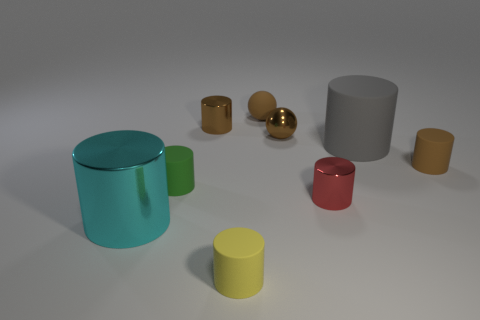Subtract all gray cylinders. How many cylinders are left? 6 Subtract all tiny red metal cylinders. How many cylinders are left? 6 Subtract all blue cylinders. Subtract all cyan blocks. How many cylinders are left? 7 Subtract all balls. How many objects are left? 7 Subtract all tiny brown shiny balls. Subtract all small rubber objects. How many objects are left? 4 Add 1 green objects. How many green objects are left? 2 Add 9 green spheres. How many green spheres exist? 9 Subtract 2 brown cylinders. How many objects are left? 7 